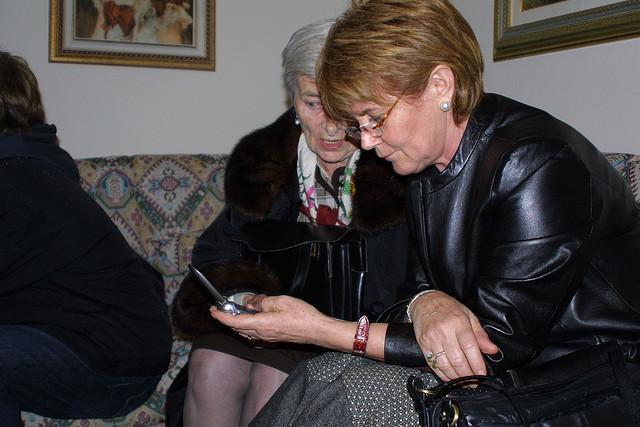How many handbags are visible?
Give a very brief answer. 2. How many people are there?
Give a very brief answer. 3. 